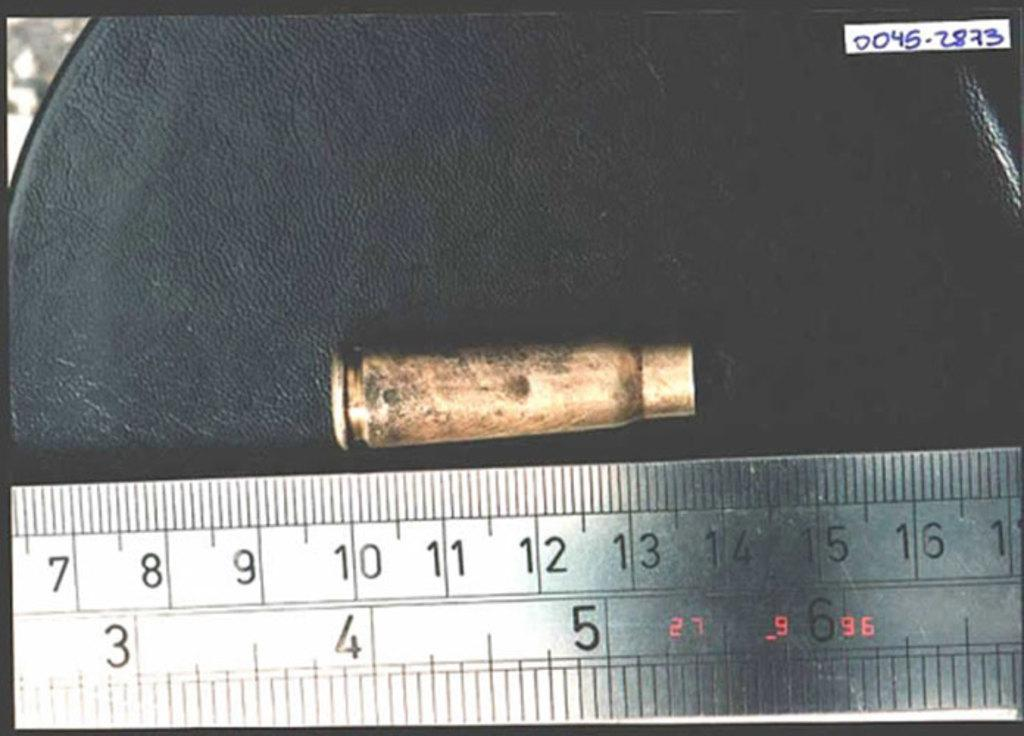<image>
Describe the image concisely. A bullet is next to a metal ruler, and measures from 10 to 14 centimeters. 